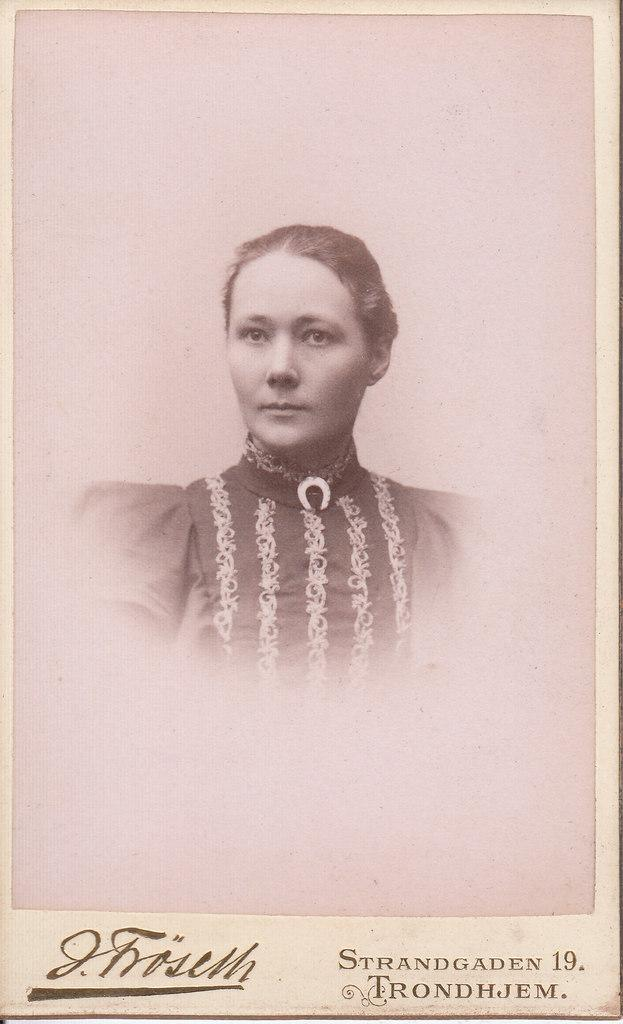Who is present in the image? There is a woman in the image. What else can be seen in the image besides the woman? There is text or writing visible in the image. What colors are predominant in the image? The image has a brown and white color scheme. Can you hear the bell ringing in the image? There is no bell present in the image, so it cannot be heard. 